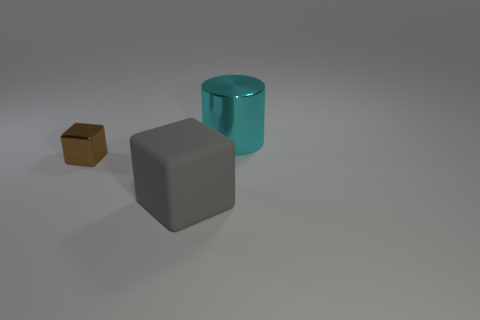How many objects are large cubes on the left side of the shiny cylinder or metal things on the left side of the large cyan object?
Provide a succinct answer. 2. Are there more big cylinders that are left of the cyan cylinder than tiny yellow metallic balls?
Give a very brief answer. No. What number of other things are there of the same shape as the big cyan shiny object?
Keep it short and to the point. 0. There is a thing that is behind the gray matte thing and in front of the big cyan metal object; what is its material?
Provide a succinct answer. Metal. How many objects are gray rubber blocks or big cyan metal blocks?
Provide a succinct answer. 1. Are there more yellow matte blocks than gray matte things?
Ensure brevity in your answer.  No. There is a metal object that is in front of the large object behind the large block; how big is it?
Make the answer very short. Small. There is another thing that is the same shape as the tiny brown metallic object; what color is it?
Give a very brief answer. Gray. How big is the rubber cube?
Your response must be concise. Large. What number of balls are either big shiny objects or gray rubber objects?
Make the answer very short. 0. 